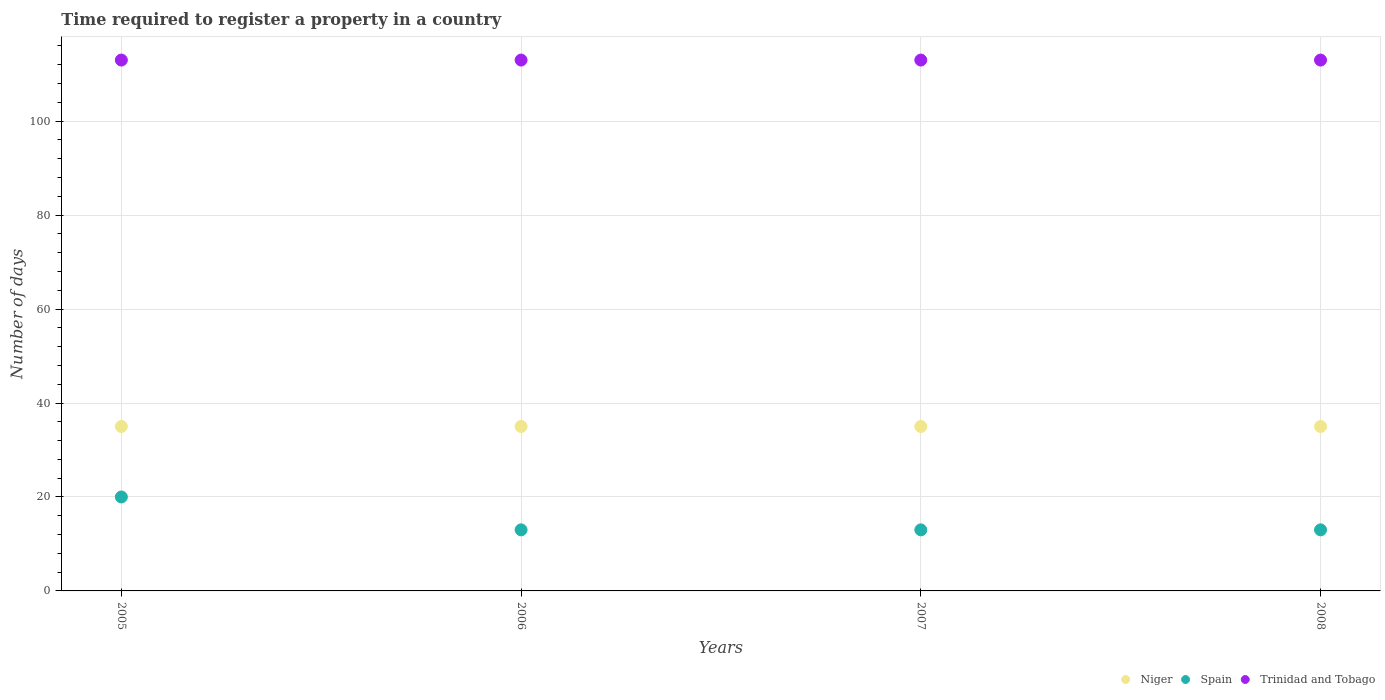How many different coloured dotlines are there?
Your answer should be very brief. 3. Is the number of dotlines equal to the number of legend labels?
Give a very brief answer. Yes. What is the number of days required to register a property in Niger in 2005?
Provide a succinct answer. 35. Across all years, what is the maximum number of days required to register a property in Trinidad and Tobago?
Your response must be concise. 113. Across all years, what is the minimum number of days required to register a property in Spain?
Give a very brief answer. 13. In which year was the number of days required to register a property in Trinidad and Tobago minimum?
Give a very brief answer. 2005. What is the total number of days required to register a property in Spain in the graph?
Keep it short and to the point. 59. What is the average number of days required to register a property in Niger per year?
Keep it short and to the point. 35. In the year 2008, what is the difference between the number of days required to register a property in Trinidad and Tobago and number of days required to register a property in Spain?
Offer a very short reply. 100. In how many years, is the number of days required to register a property in Niger greater than 40 days?
Offer a very short reply. 0. Is the difference between the number of days required to register a property in Trinidad and Tobago in 2005 and 2007 greater than the difference between the number of days required to register a property in Spain in 2005 and 2007?
Give a very brief answer. No. What is the difference between the highest and the lowest number of days required to register a property in Trinidad and Tobago?
Your answer should be compact. 0. Is the sum of the number of days required to register a property in Spain in 2006 and 2007 greater than the maximum number of days required to register a property in Trinidad and Tobago across all years?
Your answer should be compact. No. Is it the case that in every year, the sum of the number of days required to register a property in Niger and number of days required to register a property in Trinidad and Tobago  is greater than the number of days required to register a property in Spain?
Offer a terse response. Yes. How many dotlines are there?
Make the answer very short. 3. What is the difference between two consecutive major ticks on the Y-axis?
Make the answer very short. 20. Does the graph contain grids?
Offer a terse response. Yes. Where does the legend appear in the graph?
Provide a short and direct response. Bottom right. How many legend labels are there?
Ensure brevity in your answer.  3. What is the title of the graph?
Provide a succinct answer. Time required to register a property in a country. Does "Morocco" appear as one of the legend labels in the graph?
Keep it short and to the point. No. What is the label or title of the X-axis?
Offer a very short reply. Years. What is the label or title of the Y-axis?
Your answer should be very brief. Number of days. What is the Number of days in Trinidad and Tobago in 2005?
Offer a terse response. 113. What is the Number of days of Trinidad and Tobago in 2006?
Offer a terse response. 113. What is the Number of days in Spain in 2007?
Make the answer very short. 13. What is the Number of days of Trinidad and Tobago in 2007?
Your answer should be compact. 113. What is the Number of days in Spain in 2008?
Ensure brevity in your answer.  13. What is the Number of days of Trinidad and Tobago in 2008?
Your response must be concise. 113. Across all years, what is the maximum Number of days of Trinidad and Tobago?
Provide a short and direct response. 113. Across all years, what is the minimum Number of days in Trinidad and Tobago?
Provide a succinct answer. 113. What is the total Number of days of Niger in the graph?
Your response must be concise. 140. What is the total Number of days in Trinidad and Tobago in the graph?
Offer a terse response. 452. What is the difference between the Number of days of Niger in 2005 and that in 2006?
Your answer should be very brief. 0. What is the difference between the Number of days in Spain in 2005 and that in 2008?
Make the answer very short. 7. What is the difference between the Number of days of Niger in 2006 and that in 2007?
Your answer should be compact. 0. What is the difference between the Number of days in Spain in 2007 and that in 2008?
Provide a short and direct response. 0. What is the difference between the Number of days in Niger in 2005 and the Number of days in Trinidad and Tobago in 2006?
Your answer should be very brief. -78. What is the difference between the Number of days of Spain in 2005 and the Number of days of Trinidad and Tobago in 2006?
Your answer should be very brief. -93. What is the difference between the Number of days of Niger in 2005 and the Number of days of Trinidad and Tobago in 2007?
Give a very brief answer. -78. What is the difference between the Number of days of Spain in 2005 and the Number of days of Trinidad and Tobago in 2007?
Your answer should be very brief. -93. What is the difference between the Number of days of Niger in 2005 and the Number of days of Trinidad and Tobago in 2008?
Give a very brief answer. -78. What is the difference between the Number of days in Spain in 2005 and the Number of days in Trinidad and Tobago in 2008?
Your answer should be compact. -93. What is the difference between the Number of days of Niger in 2006 and the Number of days of Spain in 2007?
Make the answer very short. 22. What is the difference between the Number of days of Niger in 2006 and the Number of days of Trinidad and Tobago in 2007?
Offer a terse response. -78. What is the difference between the Number of days of Spain in 2006 and the Number of days of Trinidad and Tobago in 2007?
Your response must be concise. -100. What is the difference between the Number of days in Niger in 2006 and the Number of days in Trinidad and Tobago in 2008?
Provide a succinct answer. -78. What is the difference between the Number of days in Spain in 2006 and the Number of days in Trinidad and Tobago in 2008?
Provide a succinct answer. -100. What is the difference between the Number of days in Niger in 2007 and the Number of days in Spain in 2008?
Make the answer very short. 22. What is the difference between the Number of days of Niger in 2007 and the Number of days of Trinidad and Tobago in 2008?
Ensure brevity in your answer.  -78. What is the difference between the Number of days in Spain in 2007 and the Number of days in Trinidad and Tobago in 2008?
Ensure brevity in your answer.  -100. What is the average Number of days in Spain per year?
Your response must be concise. 14.75. What is the average Number of days of Trinidad and Tobago per year?
Provide a succinct answer. 113. In the year 2005, what is the difference between the Number of days of Niger and Number of days of Trinidad and Tobago?
Your response must be concise. -78. In the year 2005, what is the difference between the Number of days of Spain and Number of days of Trinidad and Tobago?
Give a very brief answer. -93. In the year 2006, what is the difference between the Number of days in Niger and Number of days in Spain?
Make the answer very short. 22. In the year 2006, what is the difference between the Number of days of Niger and Number of days of Trinidad and Tobago?
Give a very brief answer. -78. In the year 2006, what is the difference between the Number of days of Spain and Number of days of Trinidad and Tobago?
Make the answer very short. -100. In the year 2007, what is the difference between the Number of days of Niger and Number of days of Spain?
Offer a terse response. 22. In the year 2007, what is the difference between the Number of days in Niger and Number of days in Trinidad and Tobago?
Provide a succinct answer. -78. In the year 2007, what is the difference between the Number of days in Spain and Number of days in Trinidad and Tobago?
Offer a terse response. -100. In the year 2008, what is the difference between the Number of days of Niger and Number of days of Trinidad and Tobago?
Give a very brief answer. -78. In the year 2008, what is the difference between the Number of days of Spain and Number of days of Trinidad and Tobago?
Offer a very short reply. -100. What is the ratio of the Number of days in Niger in 2005 to that in 2006?
Make the answer very short. 1. What is the ratio of the Number of days of Spain in 2005 to that in 2006?
Give a very brief answer. 1.54. What is the ratio of the Number of days in Spain in 2005 to that in 2007?
Keep it short and to the point. 1.54. What is the ratio of the Number of days of Spain in 2005 to that in 2008?
Ensure brevity in your answer.  1.54. What is the ratio of the Number of days of Trinidad and Tobago in 2005 to that in 2008?
Your answer should be very brief. 1. What is the ratio of the Number of days in Trinidad and Tobago in 2006 to that in 2007?
Offer a very short reply. 1. What is the ratio of the Number of days of Niger in 2006 to that in 2008?
Your response must be concise. 1. What is the difference between the highest and the second highest Number of days of Spain?
Make the answer very short. 7. What is the difference between the highest and the lowest Number of days of Niger?
Your answer should be very brief. 0. What is the difference between the highest and the lowest Number of days in Spain?
Offer a terse response. 7. 